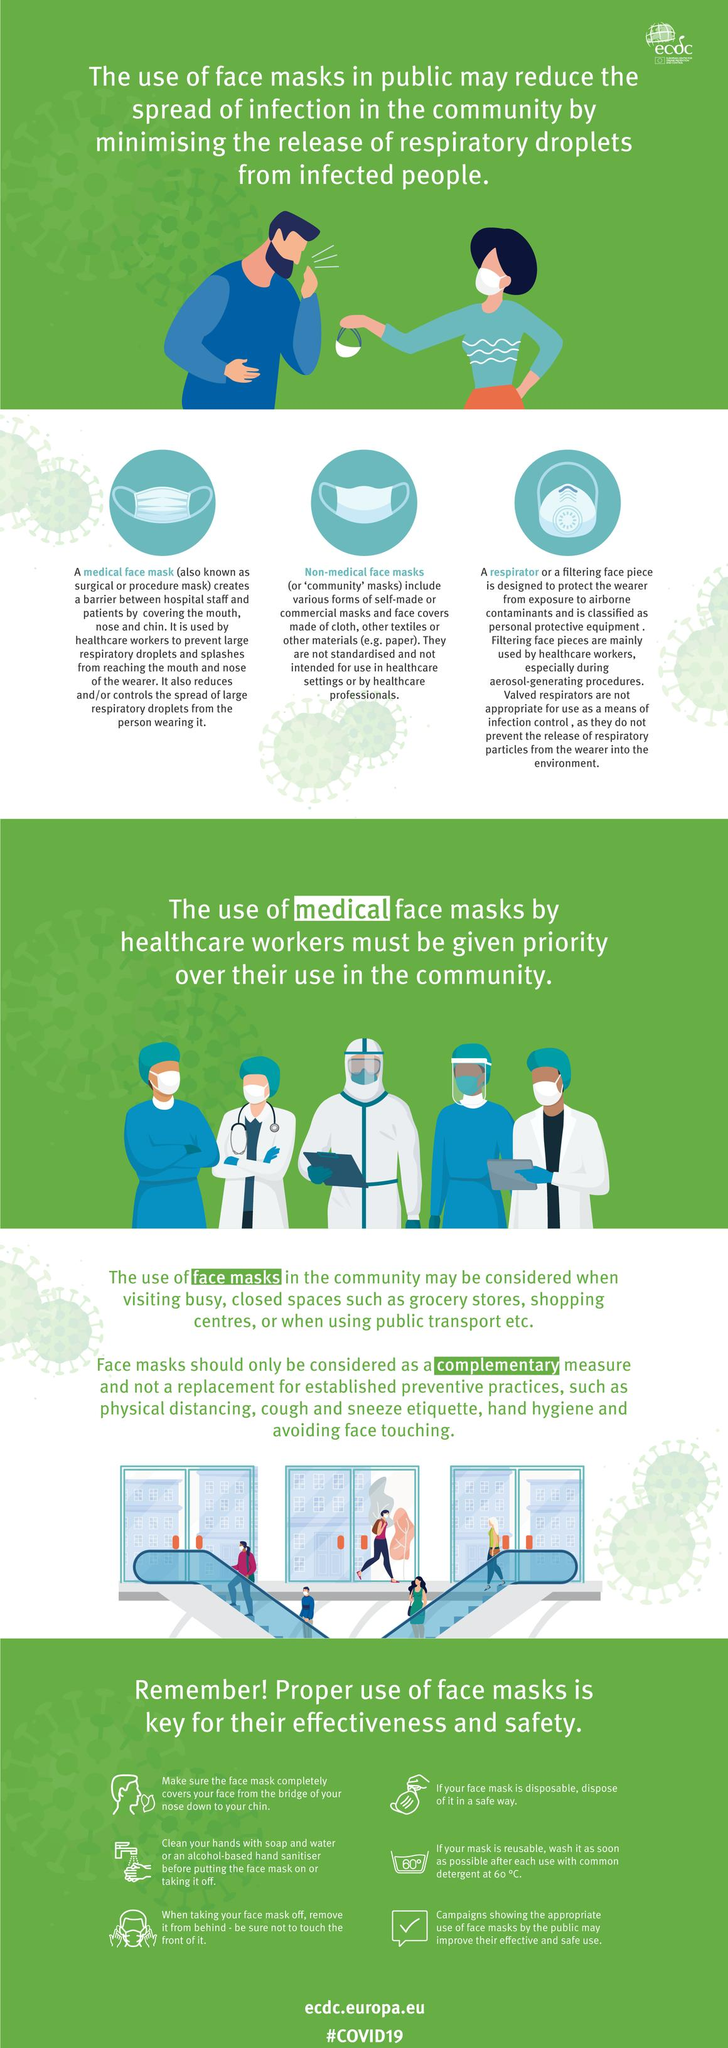Specify some key components in this picture. Health workers use medical face masks, which are specifically designed to protect against the spread of infectious diseases. A respirator mask is designed to protect the wearer from airborne contaminants. The three types of face masks depicted in this image are a medical face mask, a non-medical face mask, and a respirator. Non-medical face masks are commonly referred to as community masks. It is demonstrated that 6 steps of proper use of face masks are shown in this video. 